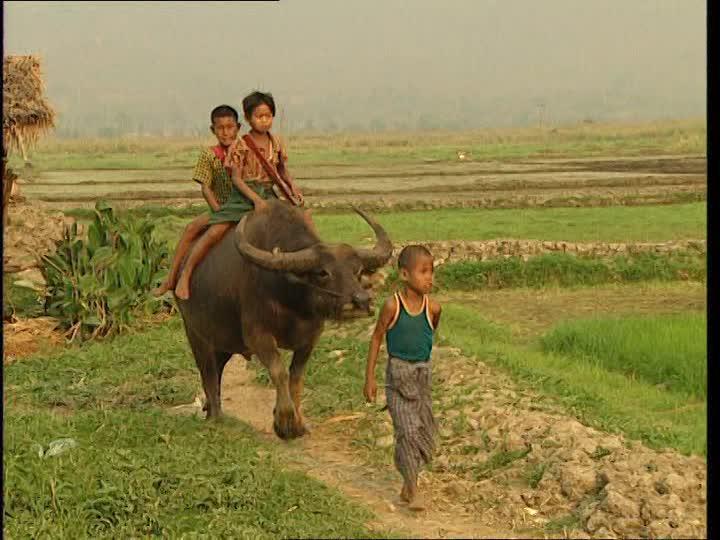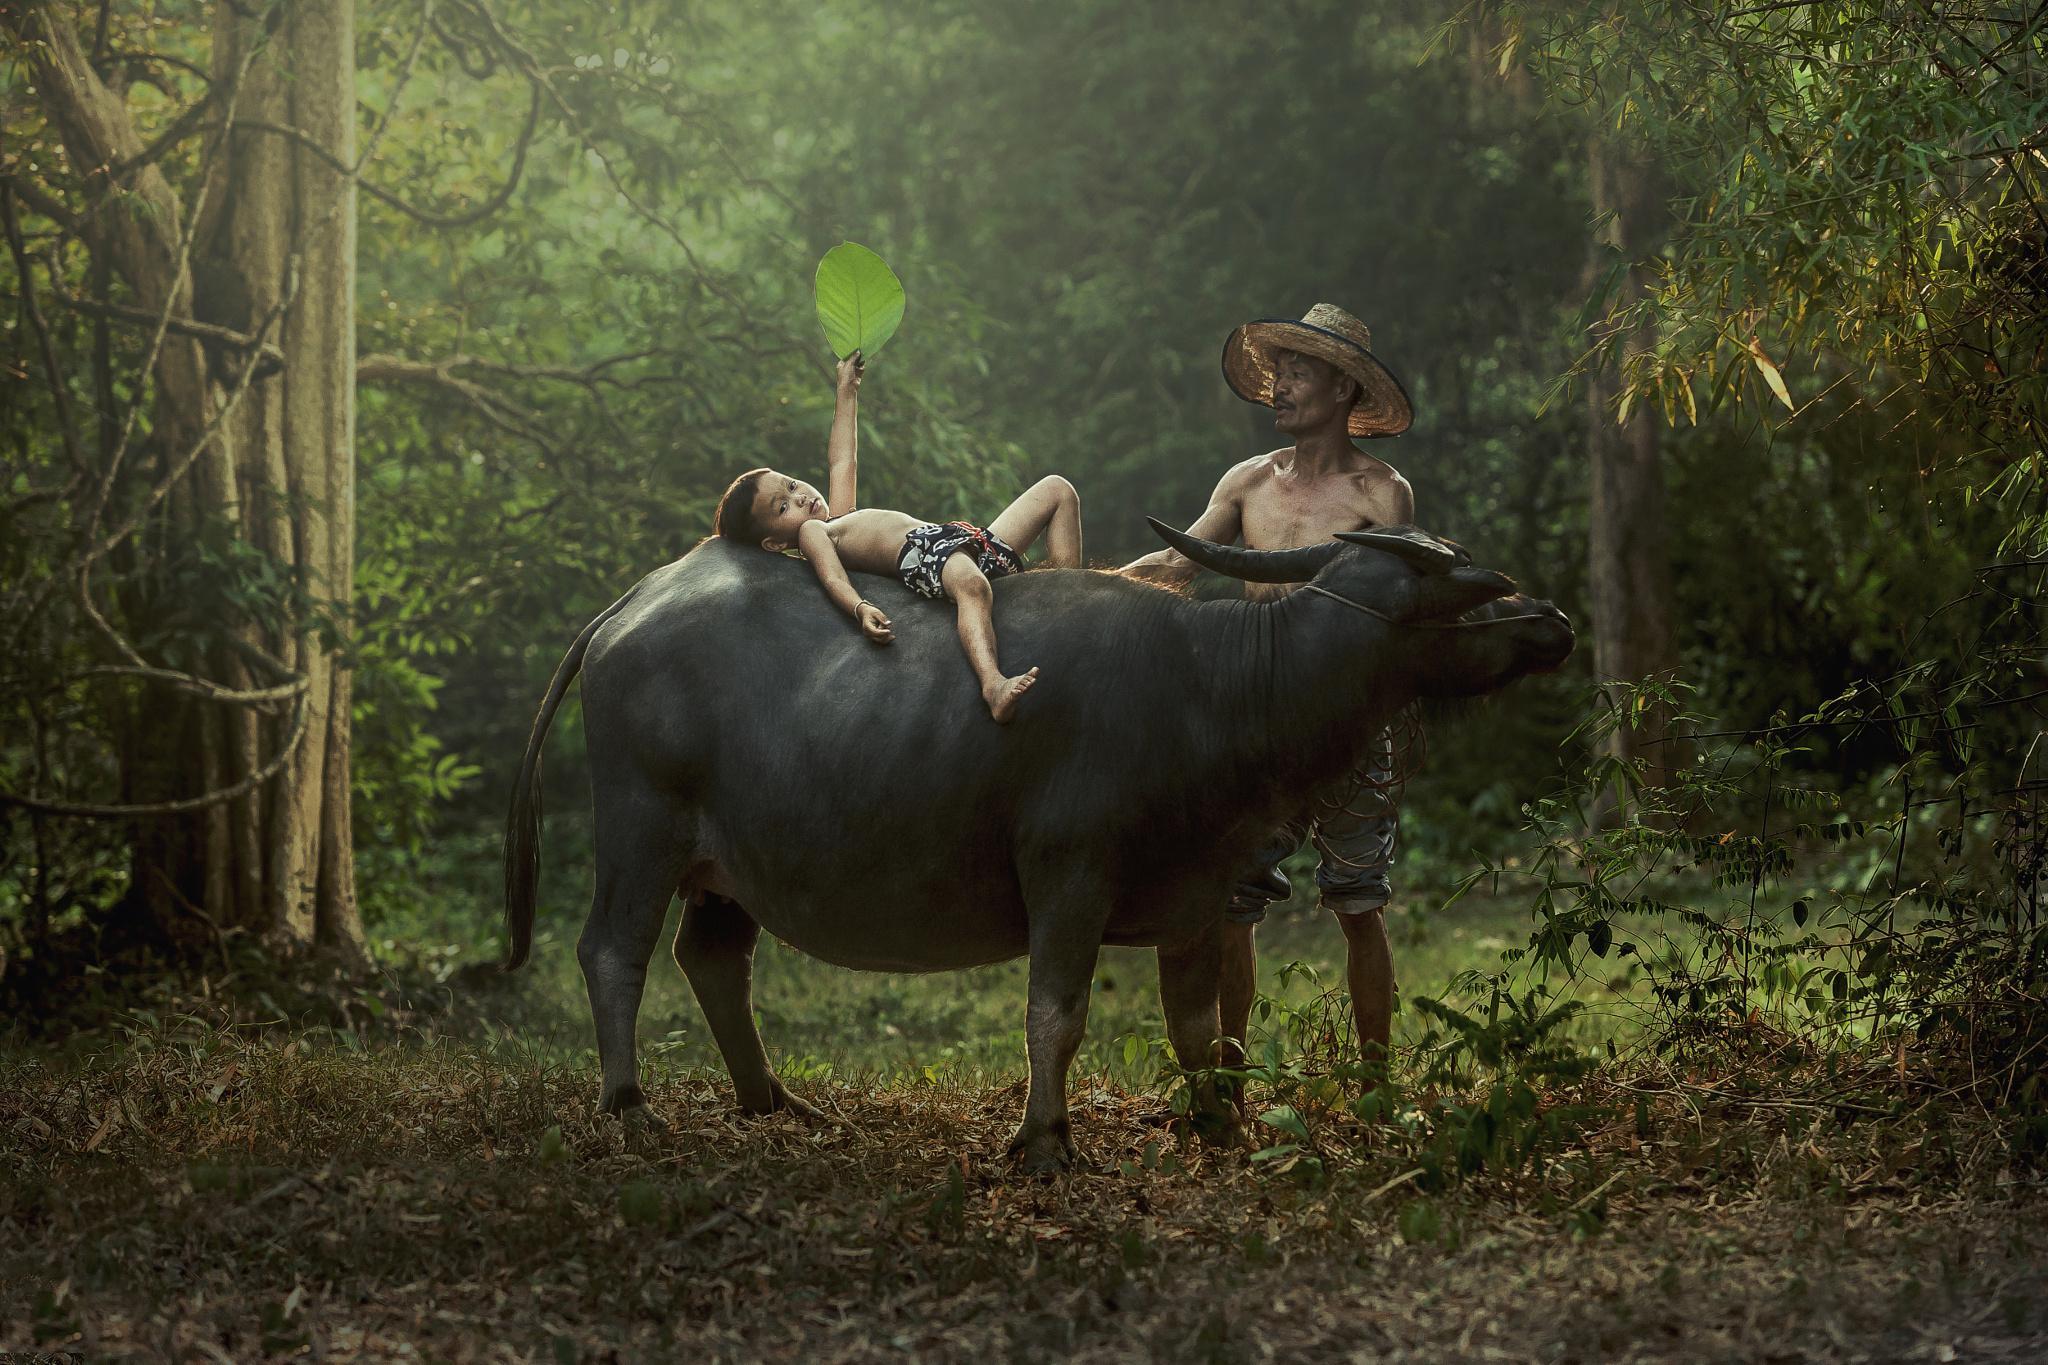The first image is the image on the left, the second image is the image on the right. Given the left and right images, does the statement "The right image shows a child straddling the back of a right-facing water buffalo, and the left image shows a boy holding a stick extended forward while on the back of a water buffalo." hold true? Answer yes or no. No. The first image is the image on the left, the second image is the image on the right. For the images displayed, is the sentence "In at least one image there are three males with short black hair and at least one male is riding an ox." factually correct? Answer yes or no. Yes. 